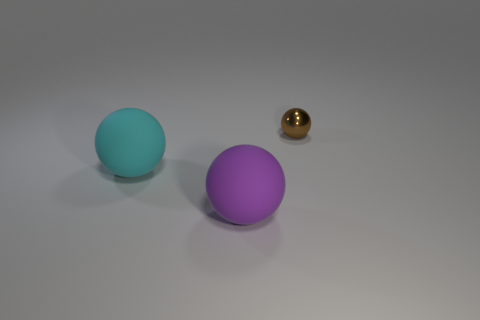Is there any indication of the size of these objects? Exact dimensions are not discernible without a frame of reference. However, if we assume the sphere sizes are within a typical range, the large purple and aqua spheres could be around the size of a small ball, while the brown sphere may be closer in size to a marble. 